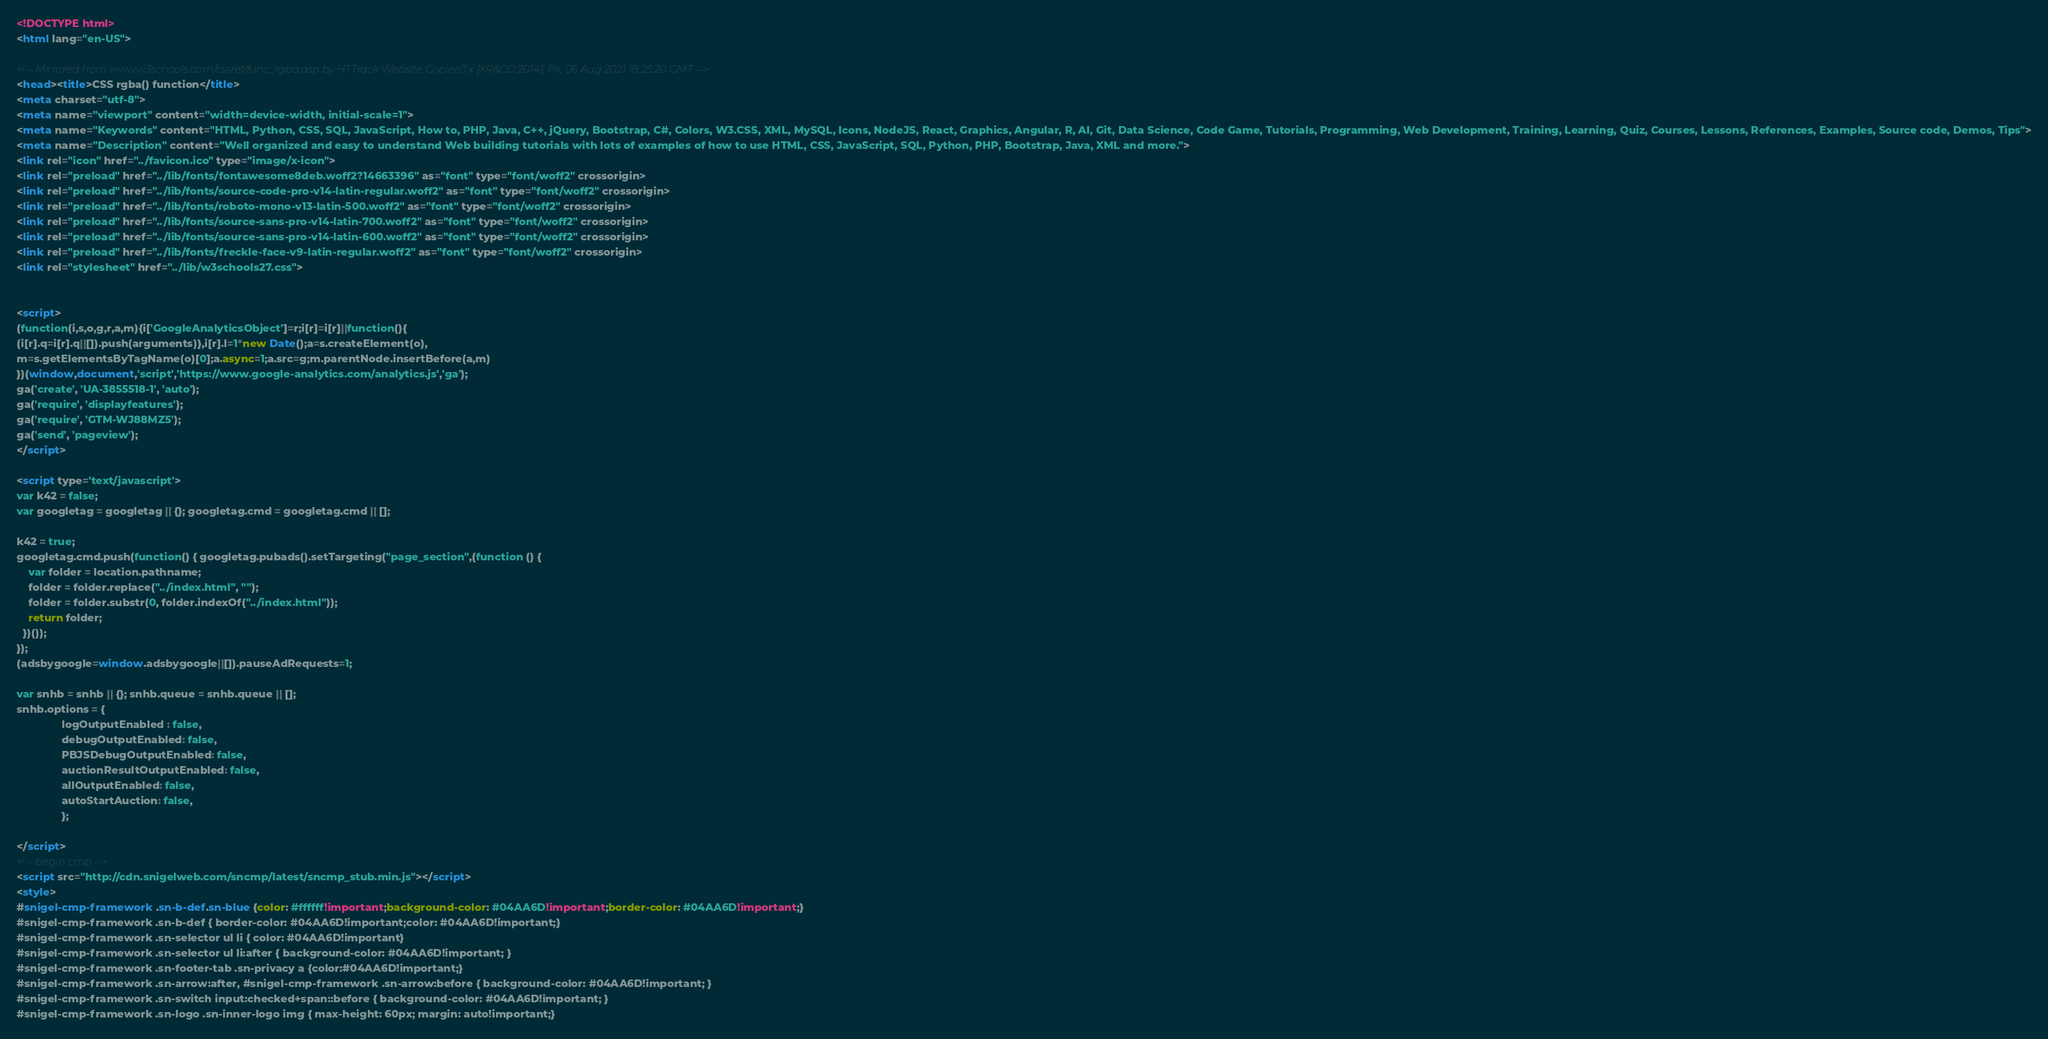<code> <loc_0><loc_0><loc_500><loc_500><_HTML_><!DOCTYPE html>
<html lang="en-US">

<!-- Mirrored from www.w3schools.com/cssref/func_rgba.asp by HTTrack Website Copier/3.x [XR&CO'2014], Fri, 06 Aug 2021 18:25:20 GMT -->
<head><title>CSS rgba() function</title>
<meta charset="utf-8">
<meta name="viewport" content="width=device-width, initial-scale=1">
<meta name="Keywords" content="HTML, Python, CSS, SQL, JavaScript, How to, PHP, Java, C++, jQuery, Bootstrap, C#, Colors, W3.CSS, XML, MySQL, Icons, NodeJS, React, Graphics, Angular, R, AI, Git, Data Science, Code Game, Tutorials, Programming, Web Development, Training, Learning, Quiz, Courses, Lessons, References, Examples, Source code, Demos, Tips">
<meta name="Description" content="Well organized and easy to understand Web building tutorials with lots of examples of how to use HTML, CSS, JavaScript, SQL, Python, PHP, Bootstrap, Java, XML and more.">
<link rel="icon" href="../favicon.ico" type="image/x-icon">
<link rel="preload" href="../lib/fonts/fontawesome8deb.woff2?14663396" as="font" type="font/woff2" crossorigin> 
<link rel="preload" href="../lib/fonts/source-code-pro-v14-latin-regular.woff2" as="font" type="font/woff2" crossorigin> 
<link rel="preload" href="../lib/fonts/roboto-mono-v13-latin-500.woff2" as="font" type="font/woff2" crossorigin> 
<link rel="preload" href="../lib/fonts/source-sans-pro-v14-latin-700.woff2" as="font" type="font/woff2" crossorigin> 
<link rel="preload" href="../lib/fonts/source-sans-pro-v14-latin-600.woff2" as="font" type="font/woff2" crossorigin> 
<link rel="preload" href="../lib/fonts/freckle-face-v9-latin-regular.woff2" as="font" type="font/woff2" crossorigin> 
<link rel="stylesheet" href="../lib/w3schools27.css">


<script>
(function(i,s,o,g,r,a,m){i['GoogleAnalyticsObject']=r;i[r]=i[r]||function(){
(i[r].q=i[r].q||[]).push(arguments)},i[r].l=1*new Date();a=s.createElement(o),
m=s.getElementsByTagName(o)[0];a.async=1;a.src=g;m.parentNode.insertBefore(a,m)
})(window,document,'script','https://www.google-analytics.com/analytics.js','ga');
ga('create', 'UA-3855518-1', 'auto');
ga('require', 'displayfeatures');
ga('require', 'GTM-WJ88MZ5');
ga('send', 'pageview');
</script>

<script type='text/javascript'>
var k42 = false;
var googletag = googletag || {}; googletag.cmd = googletag.cmd || [];

k42 = true;
googletag.cmd.push(function() { googletag.pubads().setTargeting("page_section",(function () {
    var folder = location.pathname;
    folder = folder.replace("../index.html", "");
    folder = folder.substr(0, folder.indexOf("../index.html"));
    return folder;
  })());
});  
(adsbygoogle=window.adsbygoogle||[]).pauseAdRequests=1;

var snhb = snhb || {}; snhb.queue = snhb.queue || [];
snhb.options = {
               logOutputEnabled : false,
               debugOutputEnabled: false,
               PBJSDebugOutputEnabled: false,
               auctionResultOutputEnabled: false,
               allOutputEnabled: false,
               autoStartAuction: false,
               };

</script>
<!-- begin cmp -->
<script src="http://cdn.snigelweb.com/sncmp/latest/sncmp_stub.min.js"></script>
<style>
#snigel-cmp-framework .sn-b-def.sn-blue {color: #ffffff!important;background-color: #04AA6D!important;border-color: #04AA6D!important;}
#snigel-cmp-framework .sn-b-def { border-color: #04AA6D!important;color: #04AA6D!important;}
#snigel-cmp-framework .sn-selector ul li { color: #04AA6D!important}
#snigel-cmp-framework .sn-selector ul li:after { background-color: #04AA6D!important; }
#snigel-cmp-framework .sn-footer-tab .sn-privacy a {color:#04AA6D!important;}
#snigel-cmp-framework .sn-arrow:after, #snigel-cmp-framework .sn-arrow:before { background-color: #04AA6D!important; }
#snigel-cmp-framework .sn-switch input:checked+span::before { background-color: #04AA6D!important; }
#snigel-cmp-framework .sn-logo .sn-inner-logo img { max-height: 60px; margin: auto!important;}</code> 